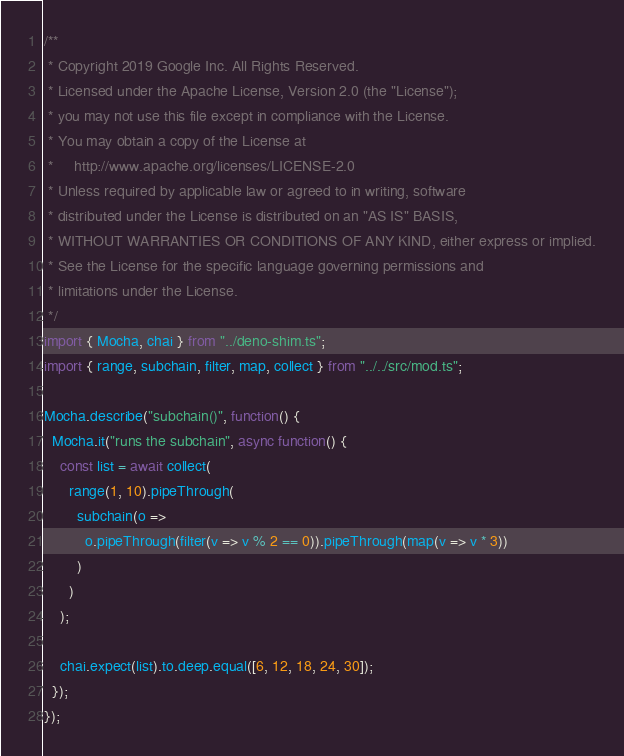Convert code to text. <code><loc_0><loc_0><loc_500><loc_500><_TypeScript_>/**
 * Copyright 2019 Google Inc. All Rights Reserved.
 * Licensed under the Apache License, Version 2.0 (the "License");
 * you may not use this file except in compliance with the License.
 * You may obtain a copy of the License at
 *     http://www.apache.org/licenses/LICENSE-2.0
 * Unless required by applicable law or agreed to in writing, software
 * distributed under the License is distributed on an "AS IS" BASIS,
 * WITHOUT WARRANTIES OR CONDITIONS OF ANY KIND, either express or implied.
 * See the License for the specific language governing permissions and
 * limitations under the License.
 */
import { Mocha, chai } from "../deno-shim.ts";
import { range, subchain, filter, map, collect } from "../../src/mod.ts";

Mocha.describe("subchain()", function() {
  Mocha.it("runs the subchain", async function() {
    const list = await collect(
      range(1, 10).pipeThrough(
        subchain(o =>
          o.pipeThrough(filter(v => v % 2 == 0)).pipeThrough(map(v => v * 3))
        )
      )
    );

    chai.expect(list).to.deep.equal([6, 12, 18, 24, 30]);
  });
});
</code> 